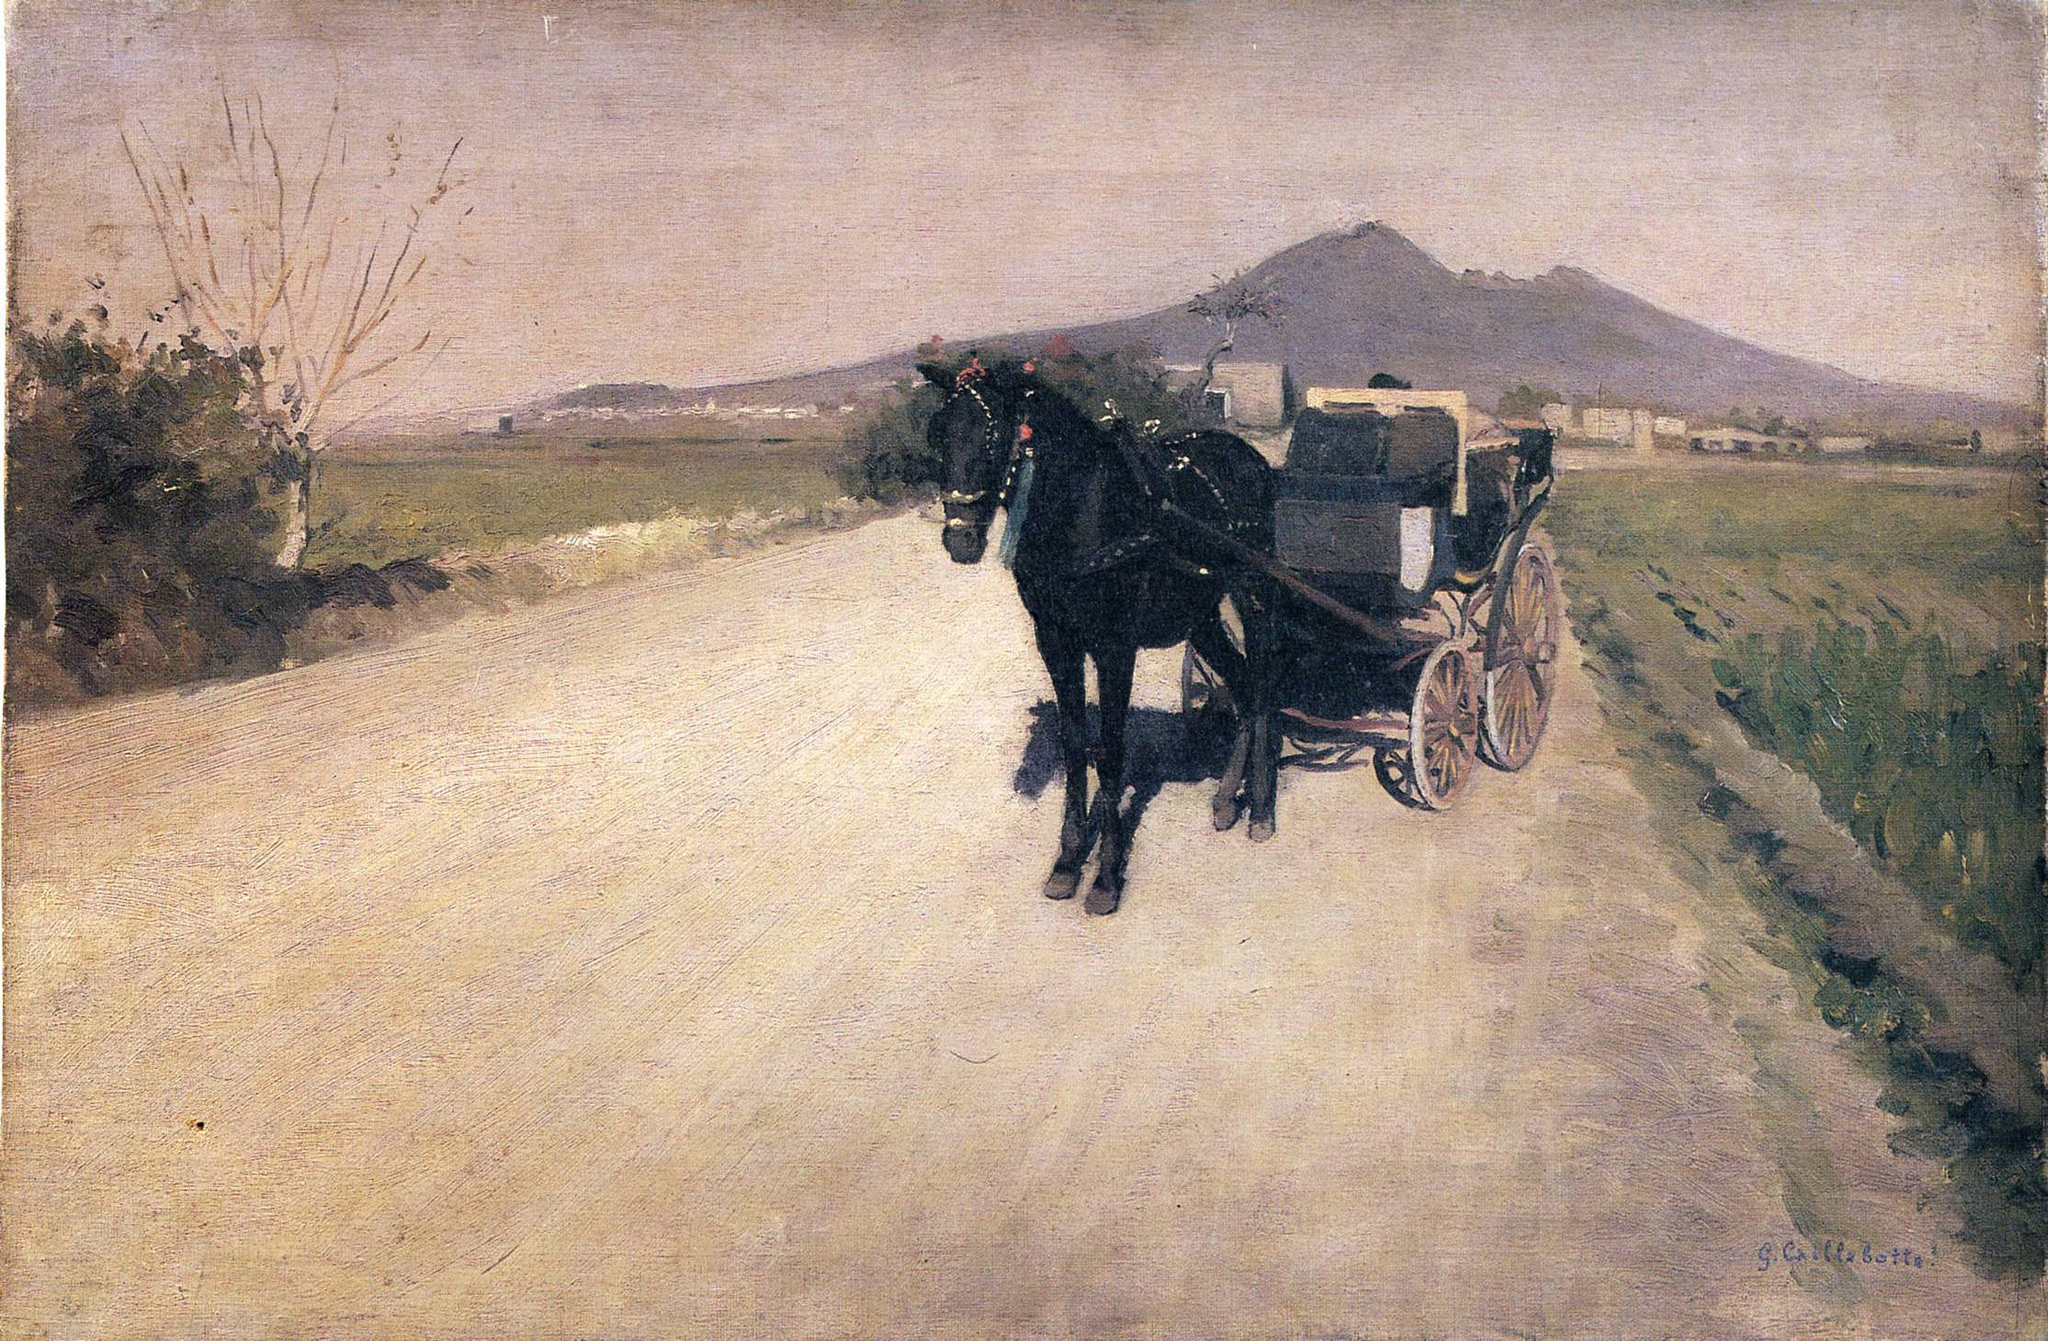What are the key elements in this picture? This compelling artwork features a somber, yet lively scene dominated by a horse-drawn carriage on a dirt road, engaging the viewer in a journey through a subtly vivid landscape. The painting, an exemplar of the Impressionist movement, likely seeks to capture the dynamic effects of natural light through its expressive brushwork and balanced earthy tones, complemented by the serene blue sky. The depiction of distant mountains and scattered buildings amidst the natural surroundings adds a layer of depth, inviting contemplation of a tranquil rural setting. The artwork is a testament to the artist whose signature suggests ‘G. Caillebotte,' renowned for his realistic portrayal of urban and rural scenes in the late 19th century. Overall, this masterful composition not only portrays a fleeting moment in time but also subtly invites viewers to reflect on the calm yet dynamic nature of everyday rural life during this era. 